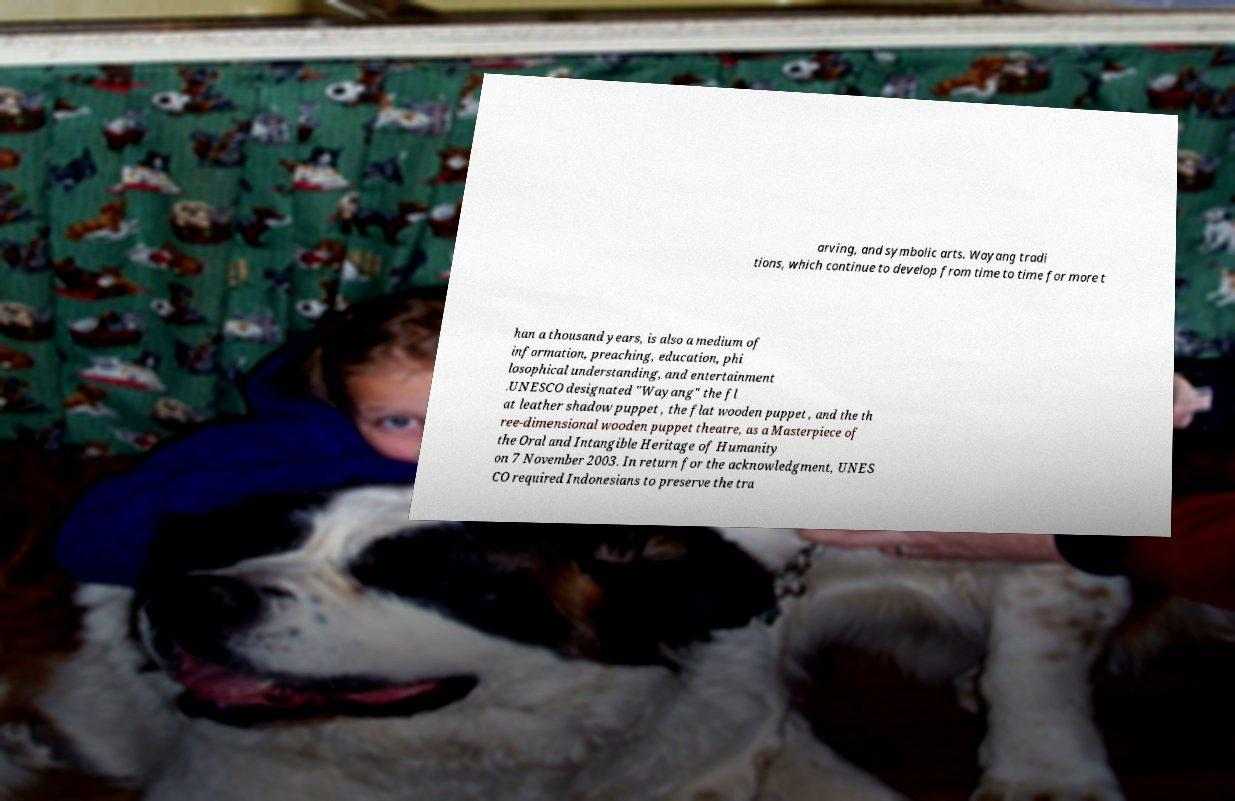I need the written content from this picture converted into text. Can you do that? arving, and symbolic arts. Wayang tradi tions, which continue to develop from time to time for more t han a thousand years, is also a medium of information, preaching, education, phi losophical understanding, and entertainment .UNESCO designated "Wayang" the fl at leather shadow puppet , the flat wooden puppet , and the th ree-dimensional wooden puppet theatre, as a Masterpiece of the Oral and Intangible Heritage of Humanity on 7 November 2003. In return for the acknowledgment, UNES CO required Indonesians to preserve the tra 